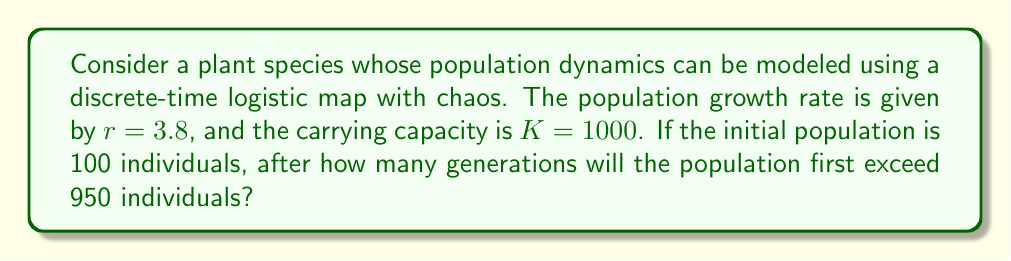Could you help me with this problem? To solve this problem, we'll use the logistic map equation and iterate it until the population exceeds 950 individuals. The steps are as follows:

1) The logistic map equation is given by:
   $$x_{n+1} = rx_n(1-x_n/K)$$
   where $x_n$ is the population at generation n, r is the growth rate, and K is the carrying capacity.

2) We normalize the equation by letting $y_n = x_n/K$:
   $$y_{n+1} = ry_n(1-y_n)$$

3) Our initial condition is $y_0 = 100/1000 = 0.1$

4) We iterate the equation:
   $y_1 = 3.8 * 0.1 * (1-0.1) = 0.342$
   $y_2 = 3.8 * 0.342 * (1-0.342) = 0.8543$
   $y_3 = 3.8 * 0.8543 * (1-0.8543) = 0.4707$
   $y_4 = 3.8 * 0.4707 * (1-0.4707) = 0.9447$

5) We stop at $y_4$ because $0.9447 * 1000 = 944.7$, which is the first value to exceed 950.

6) Therefore, it takes 4 generations for the population to first exceed 950 individuals.
Answer: 4 generations 